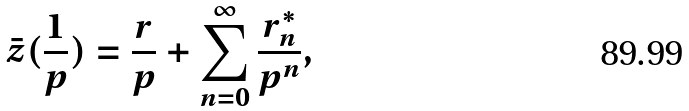<formula> <loc_0><loc_0><loc_500><loc_500>\bar { z } ( \frac { 1 } { p } ) = \frac { r } { p } + \sum _ { n = 0 } ^ { \infty } \frac { r ^ { * } _ { n } } { p ^ { n } } ,</formula> 